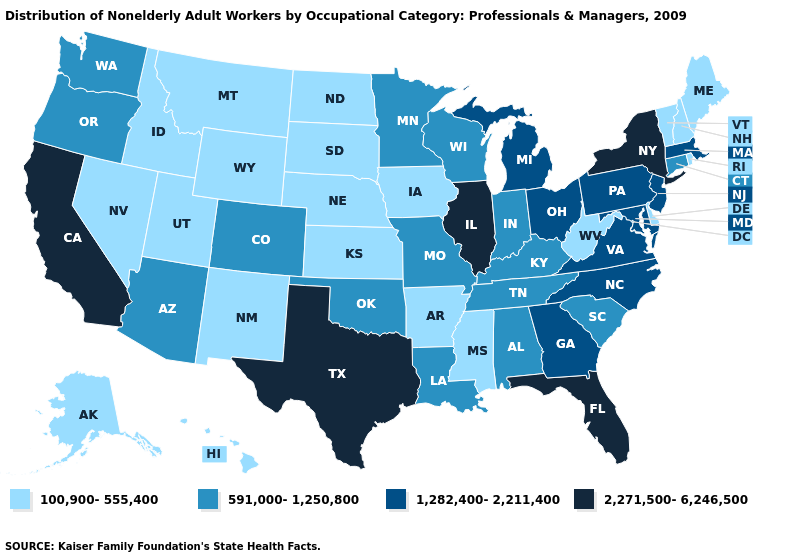Among the states that border Florida , does Alabama have the highest value?
Short answer required. No. What is the value of Kentucky?
Concise answer only. 591,000-1,250,800. Which states have the lowest value in the USA?
Write a very short answer. Alaska, Arkansas, Delaware, Hawaii, Idaho, Iowa, Kansas, Maine, Mississippi, Montana, Nebraska, Nevada, New Hampshire, New Mexico, North Dakota, Rhode Island, South Dakota, Utah, Vermont, West Virginia, Wyoming. What is the value of Alaska?
Be succinct. 100,900-555,400. What is the value of Mississippi?
Write a very short answer. 100,900-555,400. What is the highest value in the West ?
Give a very brief answer. 2,271,500-6,246,500. Among the states that border Michigan , does Indiana have the highest value?
Short answer required. No. What is the value of New Jersey?
Quick response, please. 1,282,400-2,211,400. Does Kentucky have the lowest value in the USA?
Keep it brief. No. Name the states that have a value in the range 591,000-1,250,800?
Quick response, please. Alabama, Arizona, Colorado, Connecticut, Indiana, Kentucky, Louisiana, Minnesota, Missouri, Oklahoma, Oregon, South Carolina, Tennessee, Washington, Wisconsin. What is the value of Vermont?
Short answer required. 100,900-555,400. Does the map have missing data?
Quick response, please. No. Name the states that have a value in the range 100,900-555,400?
Give a very brief answer. Alaska, Arkansas, Delaware, Hawaii, Idaho, Iowa, Kansas, Maine, Mississippi, Montana, Nebraska, Nevada, New Hampshire, New Mexico, North Dakota, Rhode Island, South Dakota, Utah, Vermont, West Virginia, Wyoming. What is the highest value in the South ?
Write a very short answer. 2,271,500-6,246,500. What is the value of Florida?
Give a very brief answer. 2,271,500-6,246,500. 